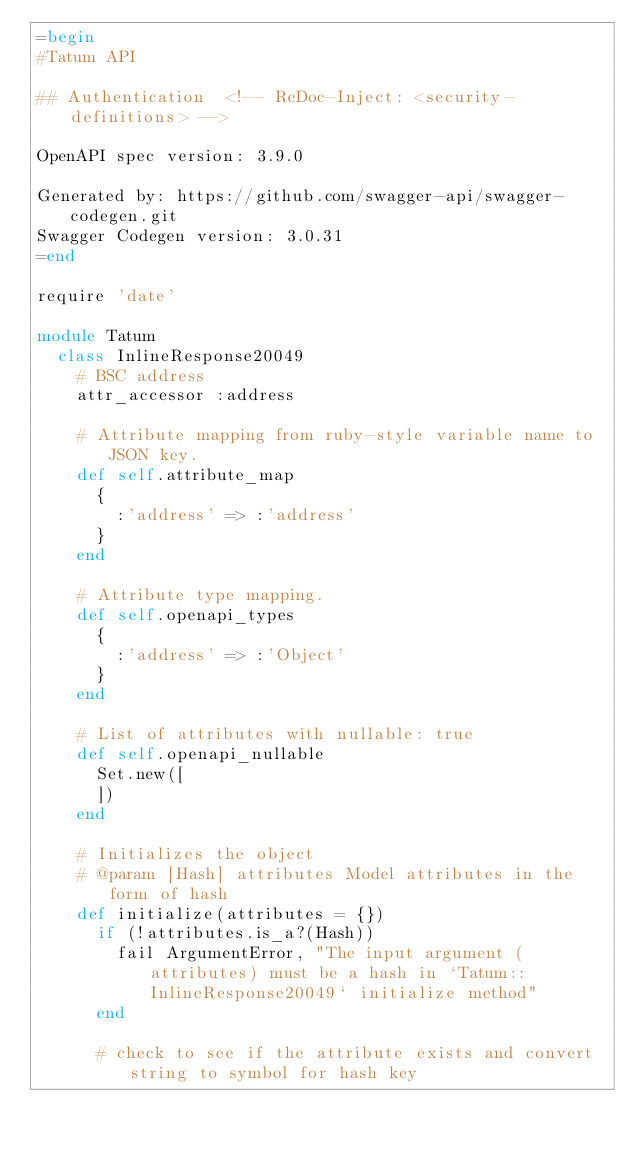Convert code to text. <code><loc_0><loc_0><loc_500><loc_500><_Ruby_>=begin
#Tatum API

## Authentication  <!-- ReDoc-Inject: <security-definitions> -->

OpenAPI spec version: 3.9.0

Generated by: https://github.com/swagger-api/swagger-codegen.git
Swagger Codegen version: 3.0.31
=end

require 'date'

module Tatum
  class InlineResponse20049
    # BSC address
    attr_accessor :address

    # Attribute mapping from ruby-style variable name to JSON key.
    def self.attribute_map
      {
        :'address' => :'address'
      }
    end

    # Attribute type mapping.
    def self.openapi_types
      {
        :'address' => :'Object'
      }
    end

    # List of attributes with nullable: true
    def self.openapi_nullable
      Set.new([
      ])
    end
  
    # Initializes the object
    # @param [Hash] attributes Model attributes in the form of hash
    def initialize(attributes = {})
      if (!attributes.is_a?(Hash))
        fail ArgumentError, "The input argument (attributes) must be a hash in `Tatum::InlineResponse20049` initialize method"
      end

      # check to see if the attribute exists and convert string to symbol for hash key</code> 